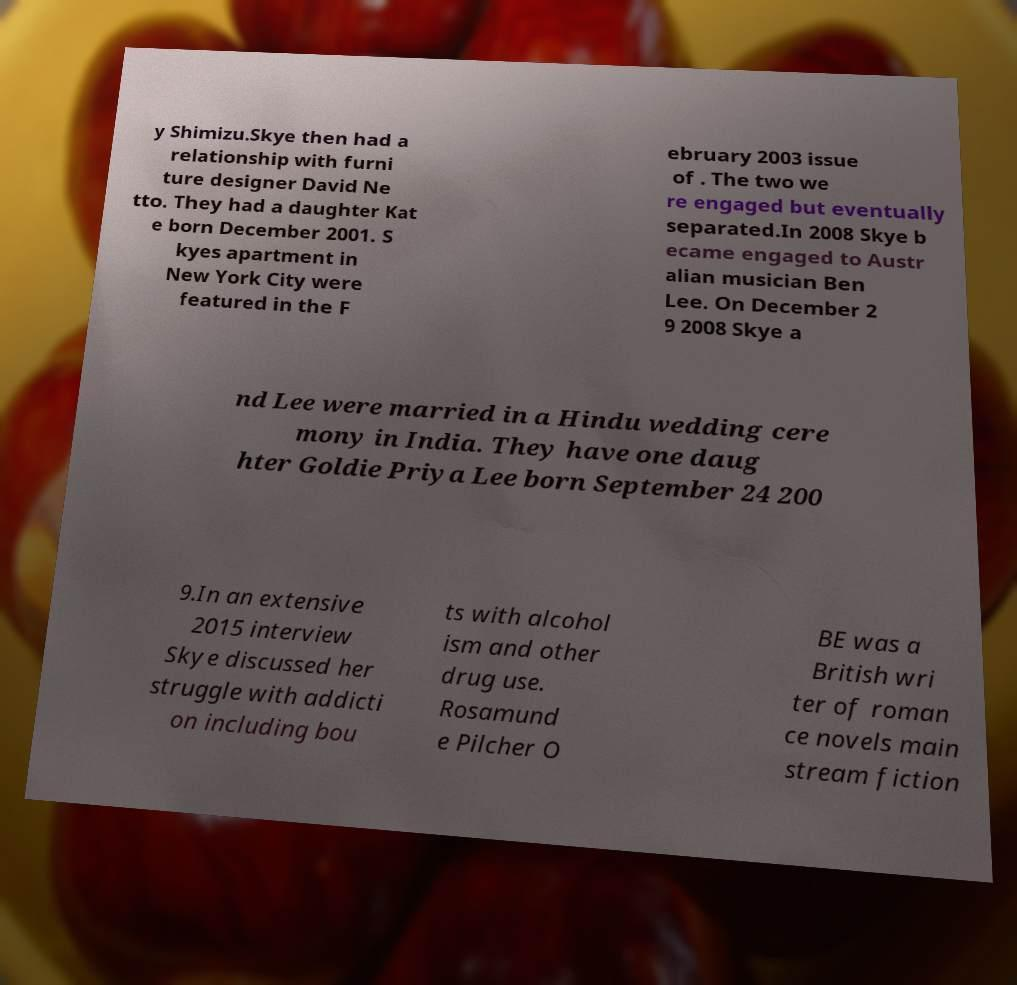Please read and relay the text visible in this image. What does it say? y Shimizu.Skye then had a relationship with furni ture designer David Ne tto. They had a daughter Kat e born December 2001. S kyes apartment in New York City were featured in the F ebruary 2003 issue of . The two we re engaged but eventually separated.In 2008 Skye b ecame engaged to Austr alian musician Ben Lee. On December 2 9 2008 Skye a nd Lee were married in a Hindu wedding cere mony in India. They have one daug hter Goldie Priya Lee born September 24 200 9.In an extensive 2015 interview Skye discussed her struggle with addicti on including bou ts with alcohol ism and other drug use. Rosamund e Pilcher O BE was a British wri ter of roman ce novels main stream fiction 